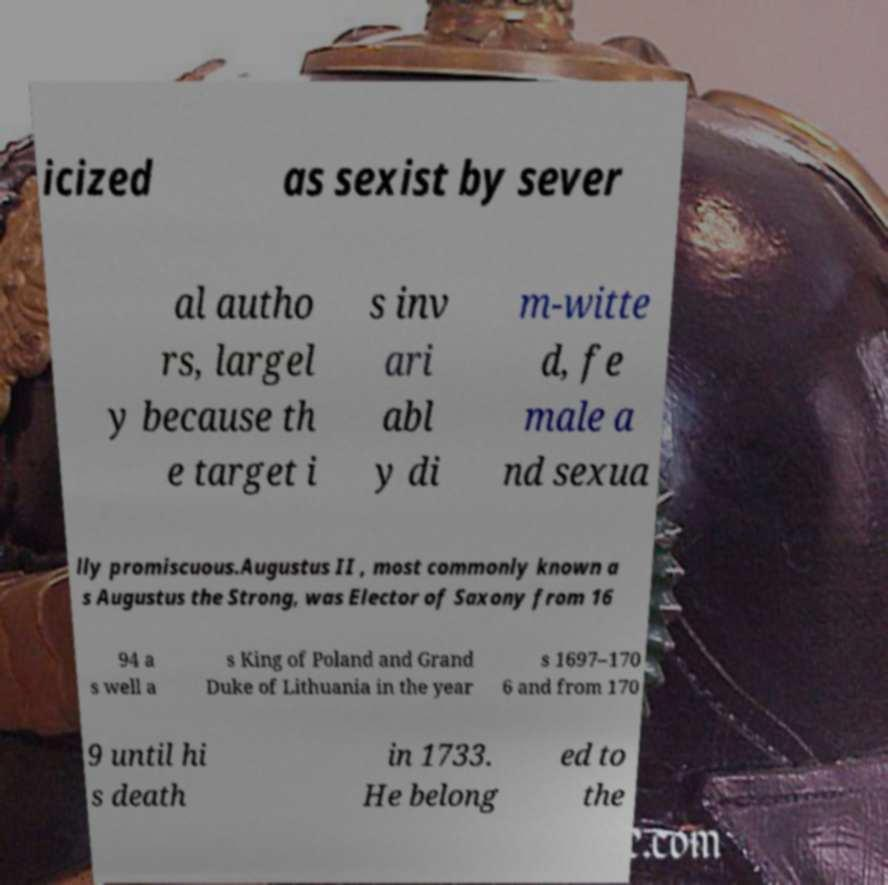For documentation purposes, I need the text within this image transcribed. Could you provide that? icized as sexist by sever al autho rs, largel y because th e target i s inv ari abl y di m-witte d, fe male a nd sexua lly promiscuous.Augustus II , most commonly known a s Augustus the Strong, was Elector of Saxony from 16 94 a s well a s King of Poland and Grand Duke of Lithuania in the year s 1697–170 6 and from 170 9 until hi s death in 1733. He belong ed to the 